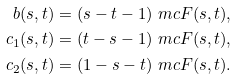<formula> <loc_0><loc_0><loc_500><loc_500>b ( s , t ) & = ( s - t - 1 ) \ m c { F } ( s , t ) , \\ c _ { 1 } ( s , t ) & = ( t - s - 1 ) \ m c { F } ( s , t ) , \\ c _ { 2 } ( s , t ) & = ( 1 - s - t ) \ m c { F } ( s , t ) .</formula> 